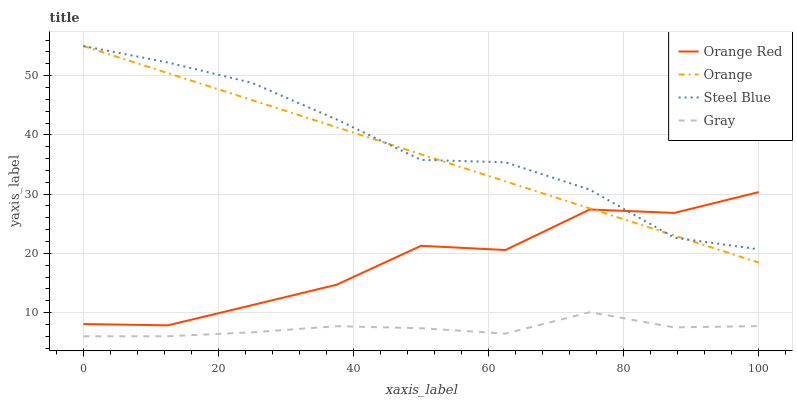Does Gray have the minimum area under the curve?
Answer yes or no. Yes. Does Steel Blue have the maximum area under the curve?
Answer yes or no. Yes. Does Orange Red have the minimum area under the curve?
Answer yes or no. No. Does Orange Red have the maximum area under the curve?
Answer yes or no. No. Is Orange the smoothest?
Answer yes or no. Yes. Is Orange Red the roughest?
Answer yes or no. Yes. Is Gray the smoothest?
Answer yes or no. No. Is Gray the roughest?
Answer yes or no. No. Does Orange Red have the lowest value?
Answer yes or no. No. Does Steel Blue have the highest value?
Answer yes or no. Yes. Does Orange Red have the highest value?
Answer yes or no. No. Is Gray less than Steel Blue?
Answer yes or no. Yes. Is Orange Red greater than Gray?
Answer yes or no. Yes. Does Gray intersect Steel Blue?
Answer yes or no. No. 